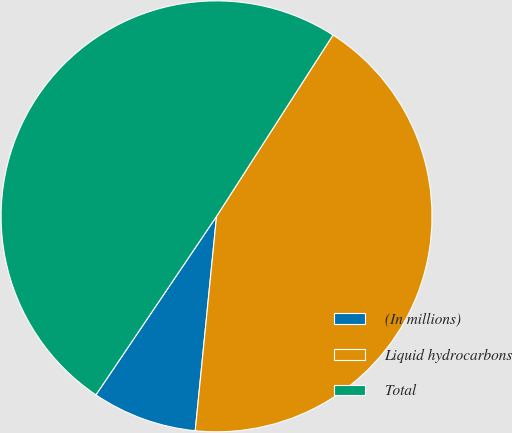<chart> <loc_0><loc_0><loc_500><loc_500><pie_chart><fcel>(In millions)<fcel>Liquid hydrocarbons<fcel>Total<nl><fcel>7.88%<fcel>42.49%<fcel>49.63%<nl></chart> 